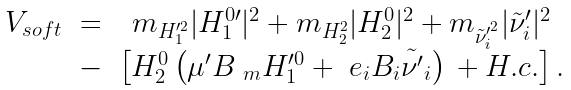<formula> <loc_0><loc_0><loc_500><loc_500>\begin{array} { c c c } V _ { s o f t } & = & m _ { H _ { 1 } ^ { \prime 2 } } | H ^ { 0 \prime } _ { 1 } | ^ { 2 } + m _ { H _ { 2 } ^ { 2 } } | H _ { 2 } ^ { 0 } | ^ { 2 } + m _ { \tilde { \nu } _ { i } ^ { \prime ^ { 2 } } } | \tilde { \nu } _ { i } ^ { \prime } | ^ { 2 } \\ & - & \left [ H _ { 2 } ^ { 0 } \left ( \mu ^ { \prime } B _ { \ m } H _ { 1 } ^ { \prime 0 } + \ e _ { i } B _ { i } \tilde { \nu ^ { \prime } } _ { i } \right ) \, + H . c . \right ] . \end{array}</formula> 